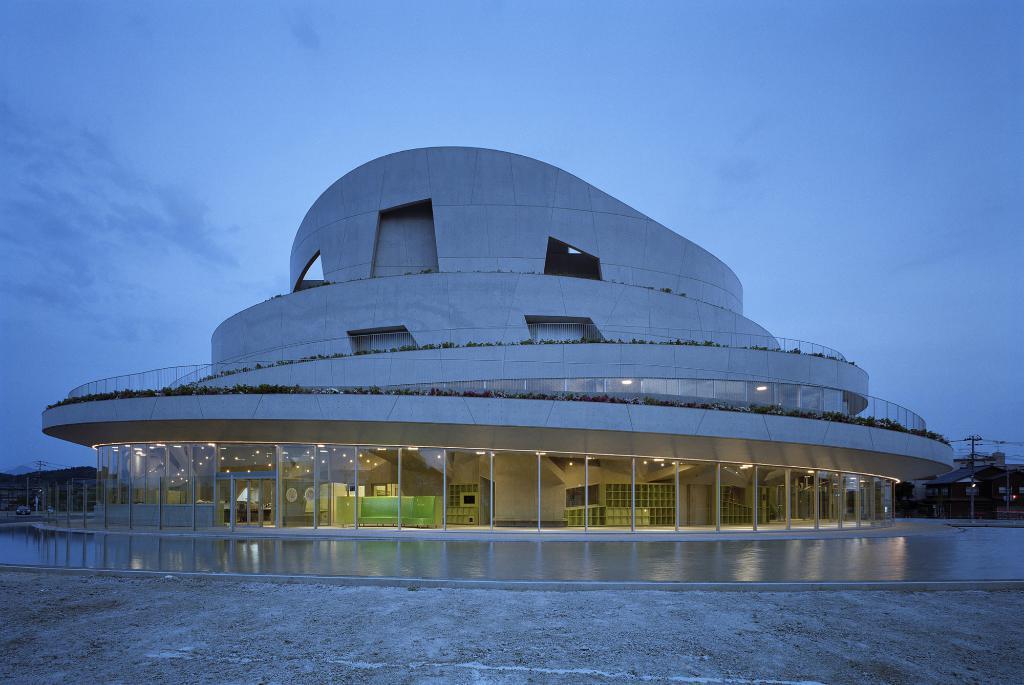Could you give a brief overview of what you see in this image? In this picture I can see a building in front and I see the lights inside the building and I see few plants on the building. In the background I see the sky. On the right side of this image I see few buildings and I see the wires. 